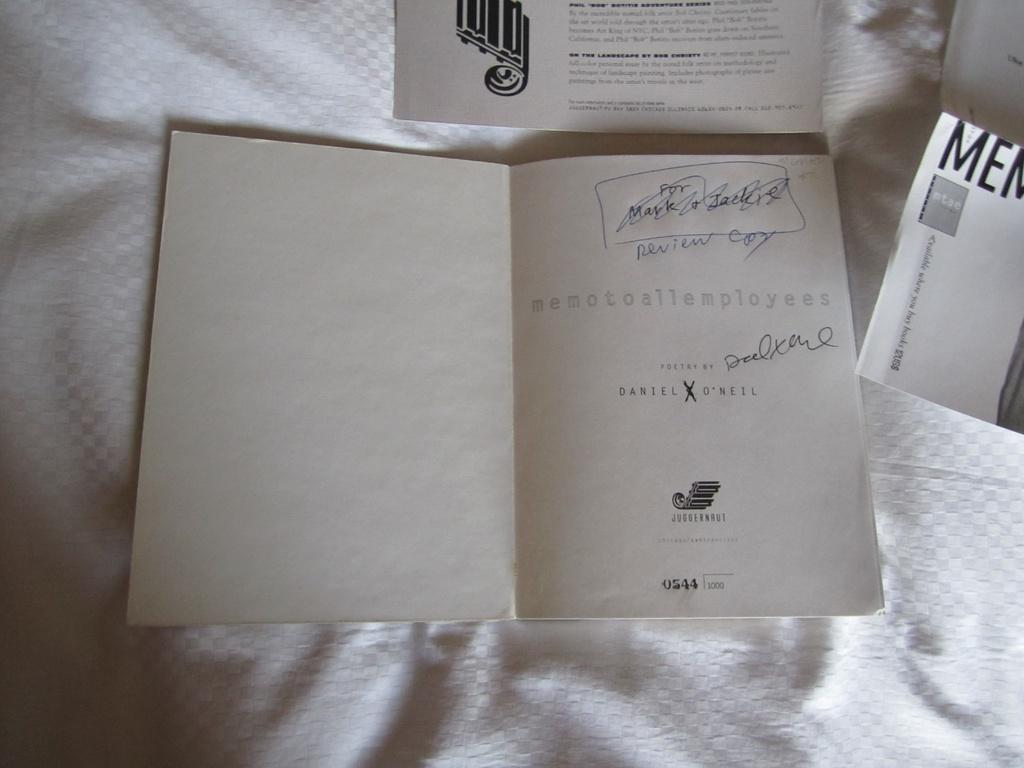Provide a one-sentence caption for the provided image. The back of a card is visible with handwriting at the top that says review.copy. 